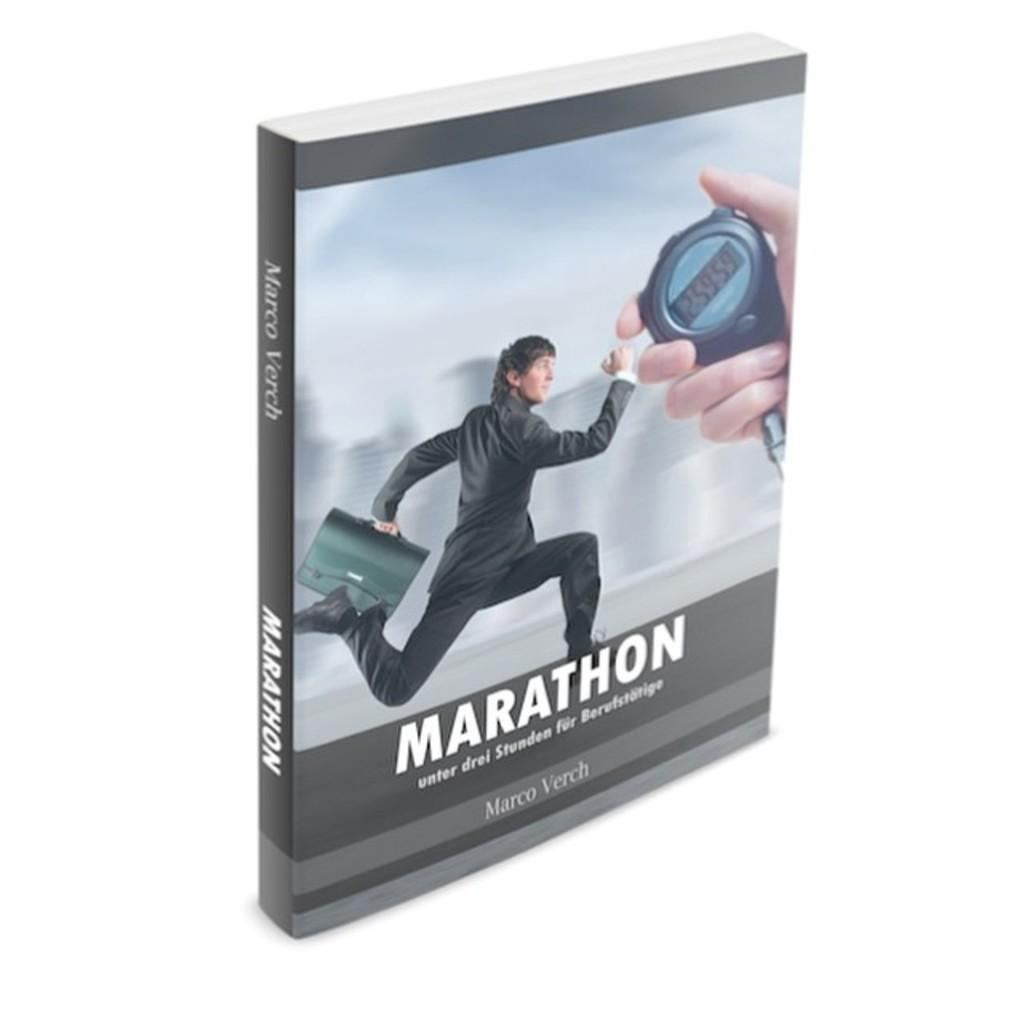Provide a one-sentence caption for the provided image. A book called MARATHON with a picture of a man in a suit running with a briefcase with a hand holding a stopwatch. 